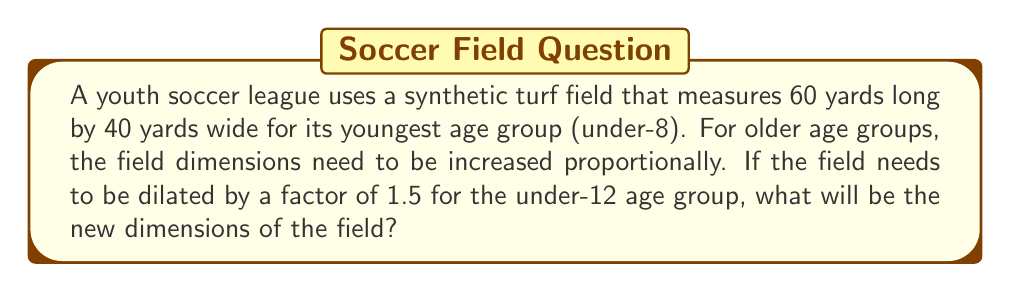Help me with this question. To solve this problem, we need to apply the concept of dilation to the given field dimensions. Dilation is a transformation that enlarges or shrinks a figure by a scale factor while maintaining its shape.

Given:
- Original field dimensions: 60 yards long by 40 yards wide
- Dilation factor: 1.5

Let's calculate the new dimensions:

1. For the length:
   $$ \text{New length} = \text{Original length} \times \text{Dilation factor} $$
   $$ \text{New length} = 60 \times 1.5 = 90 \text{ yards} $$

2. For the width:
   $$ \text{New width} = \text{Original width} \times \text{Dilation factor} $$
   $$ \text{New width} = 40 \times 1.5 = 60 \text{ yards} $$

Therefore, the new dimensions of the field after dilation will be 90 yards long by 60 yards wide.

To visualize this transformation:

[asy]
unitsize(2mm);
draw((0,0)--(60,0)--(60,40)--(0,40)--cycle);
draw((0,0)--(90,0)--(90,60)--(0,60)--cycle, dashed);
label("60 yards", (30,-2), S);
label("40 yards", (-2,20), W);
label("90 yards", (45,-6), S);
label("60 yards", (-6,30), W);
label("Original", (30,20));
label("Dilated", (45,30));
[/asy]
Answer: The new dimensions of the field for the under-12 age group will be 90 yards long by 60 yards wide. 